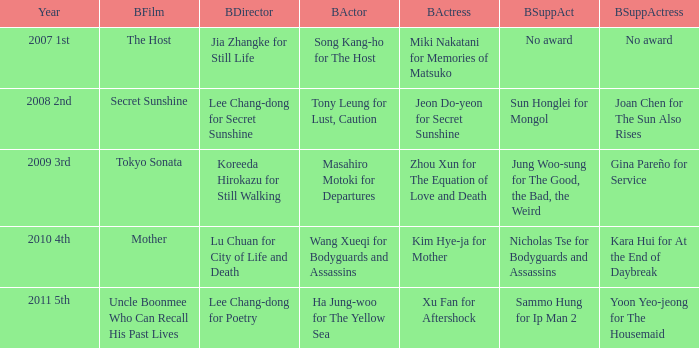Identify the top supporting actress alongside sun honglei in mongol. Joan Chen for The Sun Also Rises. 